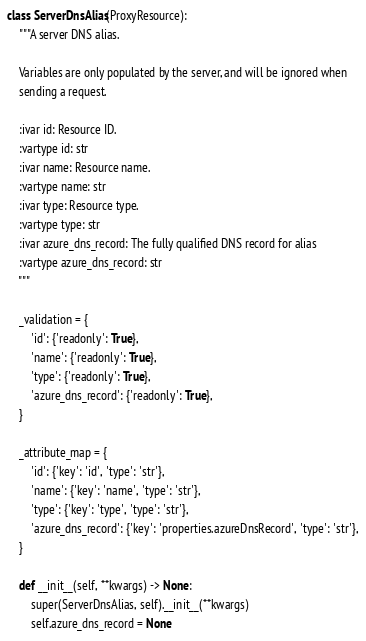Convert code to text. <code><loc_0><loc_0><loc_500><loc_500><_Python_>
class ServerDnsAlias(ProxyResource):
    """A server DNS alias.

    Variables are only populated by the server, and will be ignored when
    sending a request.

    :ivar id: Resource ID.
    :vartype id: str
    :ivar name: Resource name.
    :vartype name: str
    :ivar type: Resource type.
    :vartype type: str
    :ivar azure_dns_record: The fully qualified DNS record for alias
    :vartype azure_dns_record: str
    """

    _validation = {
        'id': {'readonly': True},
        'name': {'readonly': True},
        'type': {'readonly': True},
        'azure_dns_record': {'readonly': True},
    }

    _attribute_map = {
        'id': {'key': 'id', 'type': 'str'},
        'name': {'key': 'name', 'type': 'str'},
        'type': {'key': 'type', 'type': 'str'},
        'azure_dns_record': {'key': 'properties.azureDnsRecord', 'type': 'str'},
    }

    def __init__(self, **kwargs) -> None:
        super(ServerDnsAlias, self).__init__(**kwargs)
        self.azure_dns_record = None
</code> 